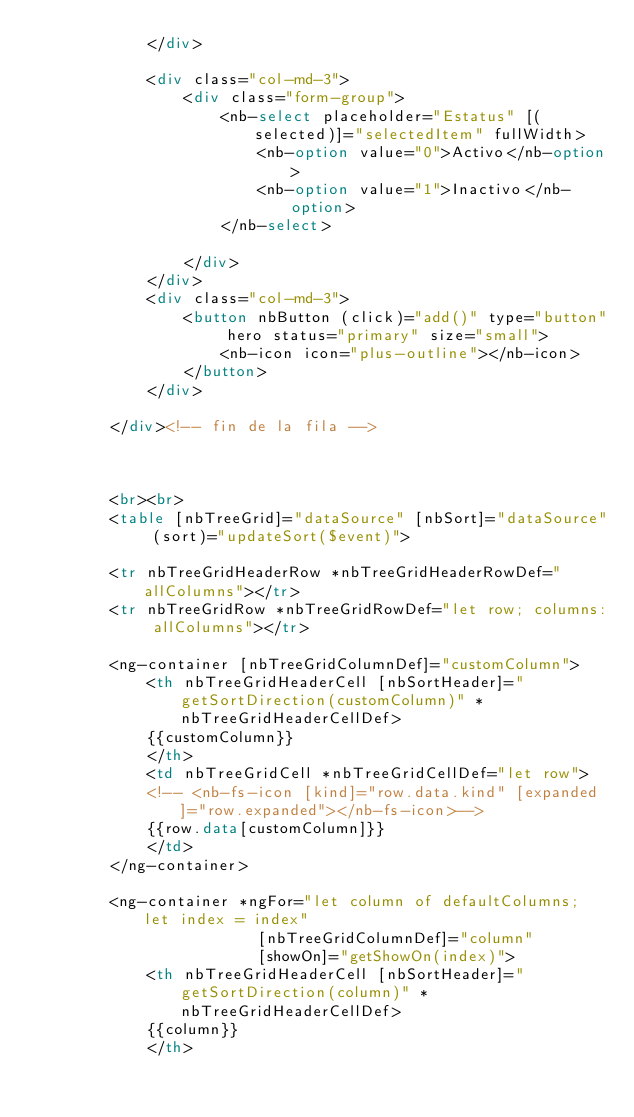<code> <loc_0><loc_0><loc_500><loc_500><_HTML_>            </div>
           
            <div class="col-md-3">
                <div class="form-group">
                    <nb-select placeholder="Estatus" [(selected)]="selectedItem" fullWidth>
                        <nb-option value="0">Activo</nb-option>
                        <nb-option value="1">Inactivo</nb-option>
                    </nb-select>
                    
                </div>
            </div>
            <div class="col-md-3">
                <button nbButton (click)="add()" type="button" hero status="primary" size="small">
                    <nb-icon icon="plus-outline"></nb-icon>
                </button>
            </div>
           
        </div><!-- fin de la fila -->



        <br><br>
        <table [nbTreeGrid]="dataSource" [nbSort]="dataSource" (sort)="updateSort($event)">

        <tr nbTreeGridHeaderRow *nbTreeGridHeaderRowDef="allColumns"></tr>
        <tr nbTreeGridRow *nbTreeGridRowDef="let row; columns: allColumns"></tr>

        <ng-container [nbTreeGridColumnDef]="customColumn">
            <th nbTreeGridHeaderCell [nbSortHeader]="getSortDirection(customColumn)" *nbTreeGridHeaderCellDef>
            {{customColumn}}
            </th>
            <td nbTreeGridCell *nbTreeGridCellDef="let row">
            <!-- <nb-fs-icon [kind]="row.data.kind" [expanded]="row.expanded"></nb-fs-icon>-->    
            {{row.data[customColumn]}}
            </td>
        </ng-container>

        <ng-container *ngFor="let column of defaultColumns; let index = index"
                        [nbTreeGridColumnDef]="column"
                        [showOn]="getShowOn(index)">
            <th nbTreeGridHeaderCell [nbSortHeader]="getSortDirection(column)" *nbTreeGridHeaderCellDef>
            {{column}}
            </th></code> 